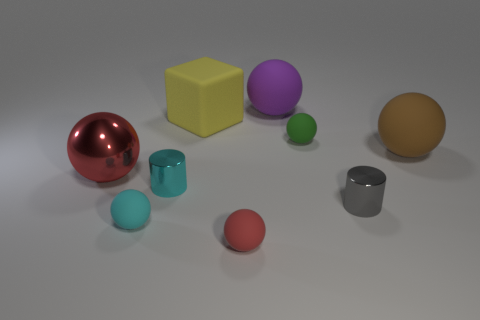Subtract all small red rubber spheres. How many spheres are left? 5 Subtract all cyan cylinders. How many cylinders are left? 1 Subtract 1 cubes. How many cubes are left? 0 Subtract all brown cylinders. How many purple blocks are left? 0 Subtract all gray cylinders. Subtract all green things. How many objects are left? 7 Add 6 gray things. How many gray things are left? 7 Add 3 big red shiny balls. How many big red shiny balls exist? 4 Subtract 1 brown spheres. How many objects are left? 8 Subtract all cylinders. How many objects are left? 7 Subtract all gray spheres. Subtract all gray cylinders. How many spheres are left? 6 